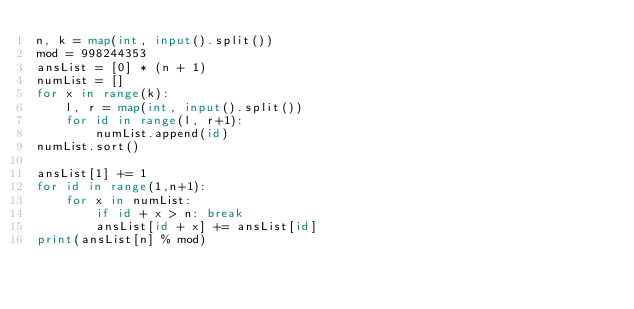<code> <loc_0><loc_0><loc_500><loc_500><_Python_>n, k = map(int, input().split())
mod = 998244353
ansList = [0] * (n + 1)
numList = []
for x in range(k):
    l, r = map(int, input().split())
    for id in range(l, r+1):
        numList.append(id)
numList.sort()

ansList[1] += 1
for id in range(1,n+1):
    for x in numList:
        if id + x > n: break 
        ansList[id + x] += ansList[id]
print(ansList[n] % mod)</code> 